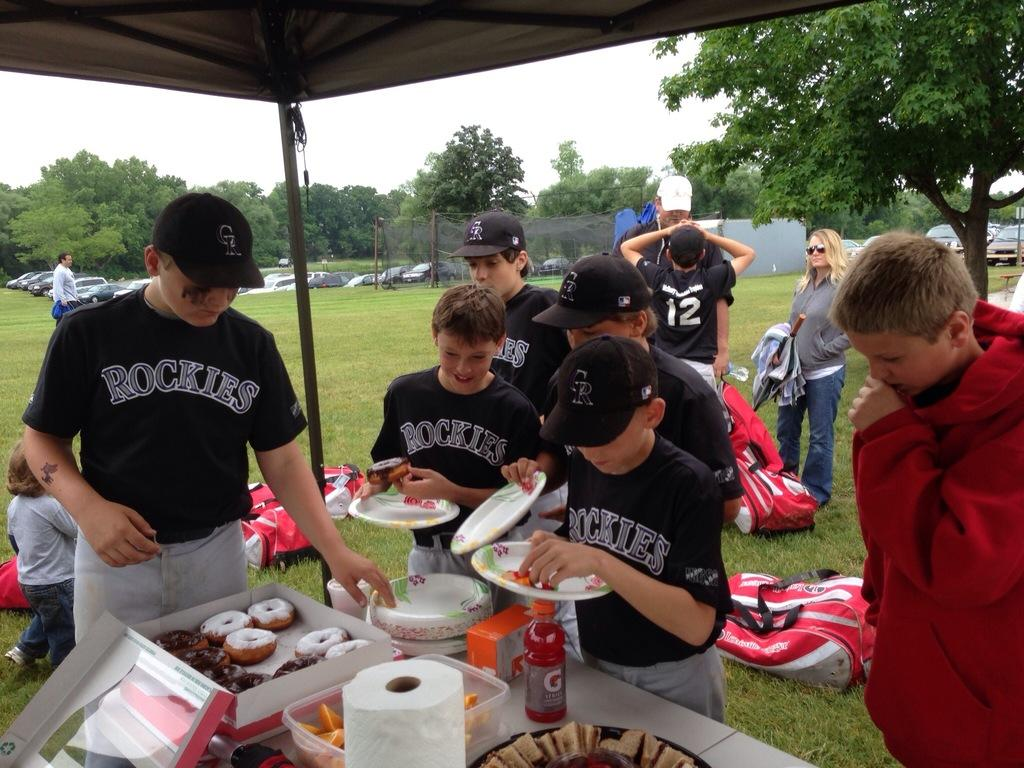<image>
Give a short and clear explanation of the subsequent image. Several boys in Rockies uniforms gather around a box of donuts. 